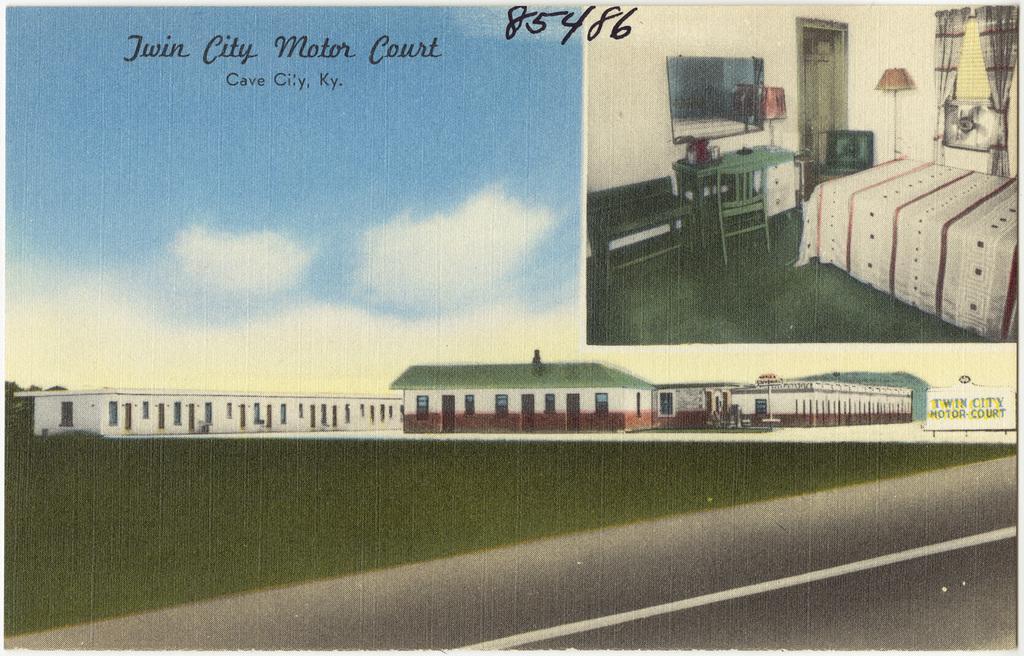Describe this image in one or two sentences. This is a picture of the poster. We can see some information. In this picture we can see the sky, building, road, television, chair, desk, bed, mattress, curtains and few objects. 